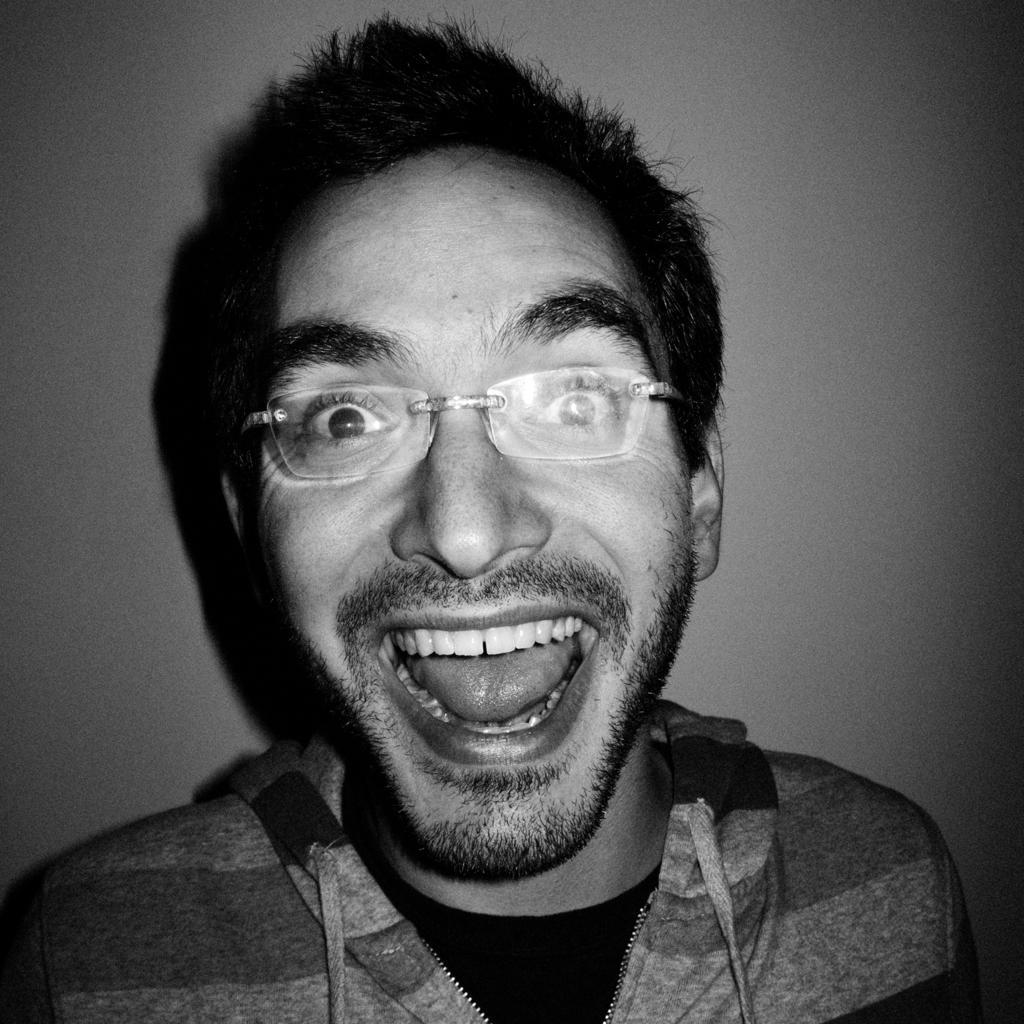How would you summarize this image in a sentence or two? As we can see in the image there is a man wearing spectacles and jacket. Behind him there is a wall. 